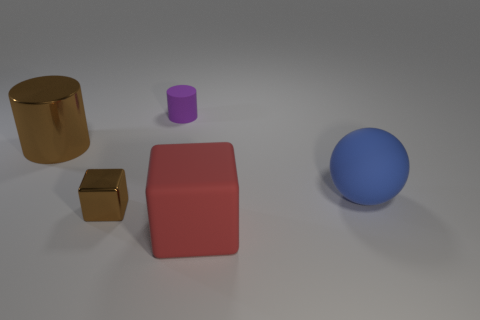Are there any red matte cubes left of the matte cube?
Provide a short and direct response. No. Is there any other thing of the same color as the big rubber ball?
Keep it short and to the point. No. How many cylinders are either small gray shiny things or large blue rubber objects?
Make the answer very short. 0. How many objects are both behind the red object and on the right side of the tiny brown metal object?
Ensure brevity in your answer.  2. Are there the same number of blue balls that are to the left of the tiny cylinder and big things behind the brown block?
Your answer should be very brief. No. There is a matte thing left of the big matte cube; does it have the same shape as the large brown object?
Offer a very short reply. Yes. There is a small object behind the big rubber object that is behind the big matte object that is in front of the sphere; what shape is it?
Ensure brevity in your answer.  Cylinder. There is a tiny thing that is the same color as the big metallic cylinder; what shape is it?
Your answer should be very brief. Cube. The thing that is both in front of the big metal cylinder and left of the purple object is made of what material?
Provide a short and direct response. Metal. Are there fewer spheres than purple matte balls?
Your answer should be compact. No. 